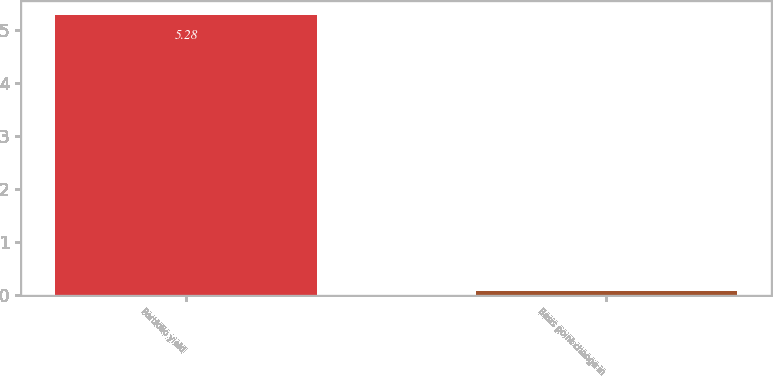<chart> <loc_0><loc_0><loc_500><loc_500><bar_chart><fcel>Portfolio yield<fcel>Basis point change in<nl><fcel>5.28<fcel>0.08<nl></chart> 